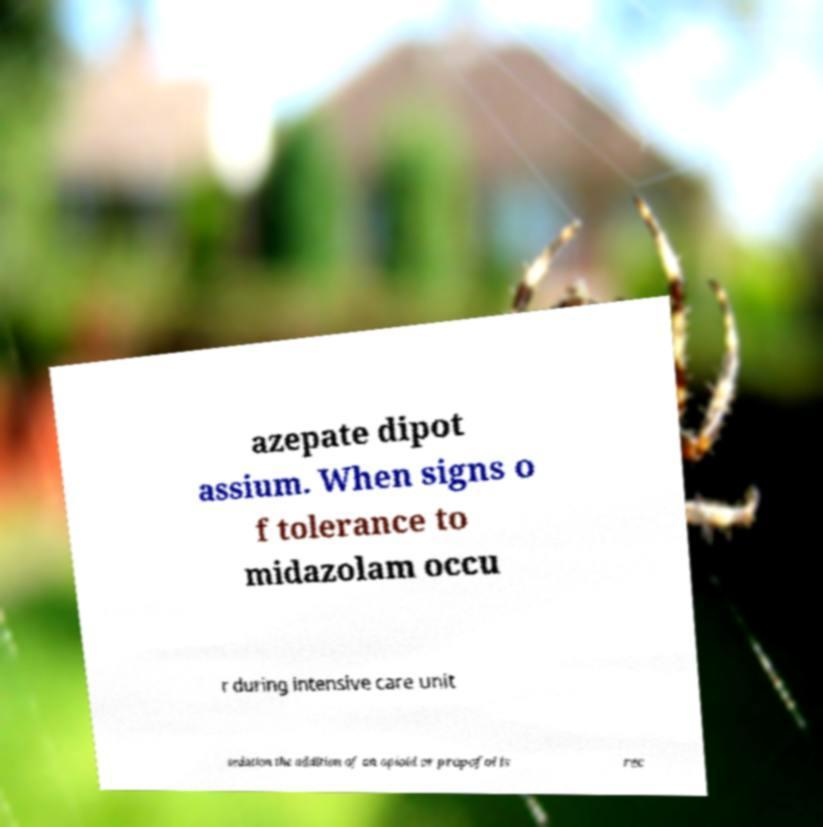Could you assist in decoding the text presented in this image and type it out clearly? azepate dipot assium. When signs o f tolerance to midazolam occu r during intensive care unit sedation the addition of an opioid or propofol is rec 